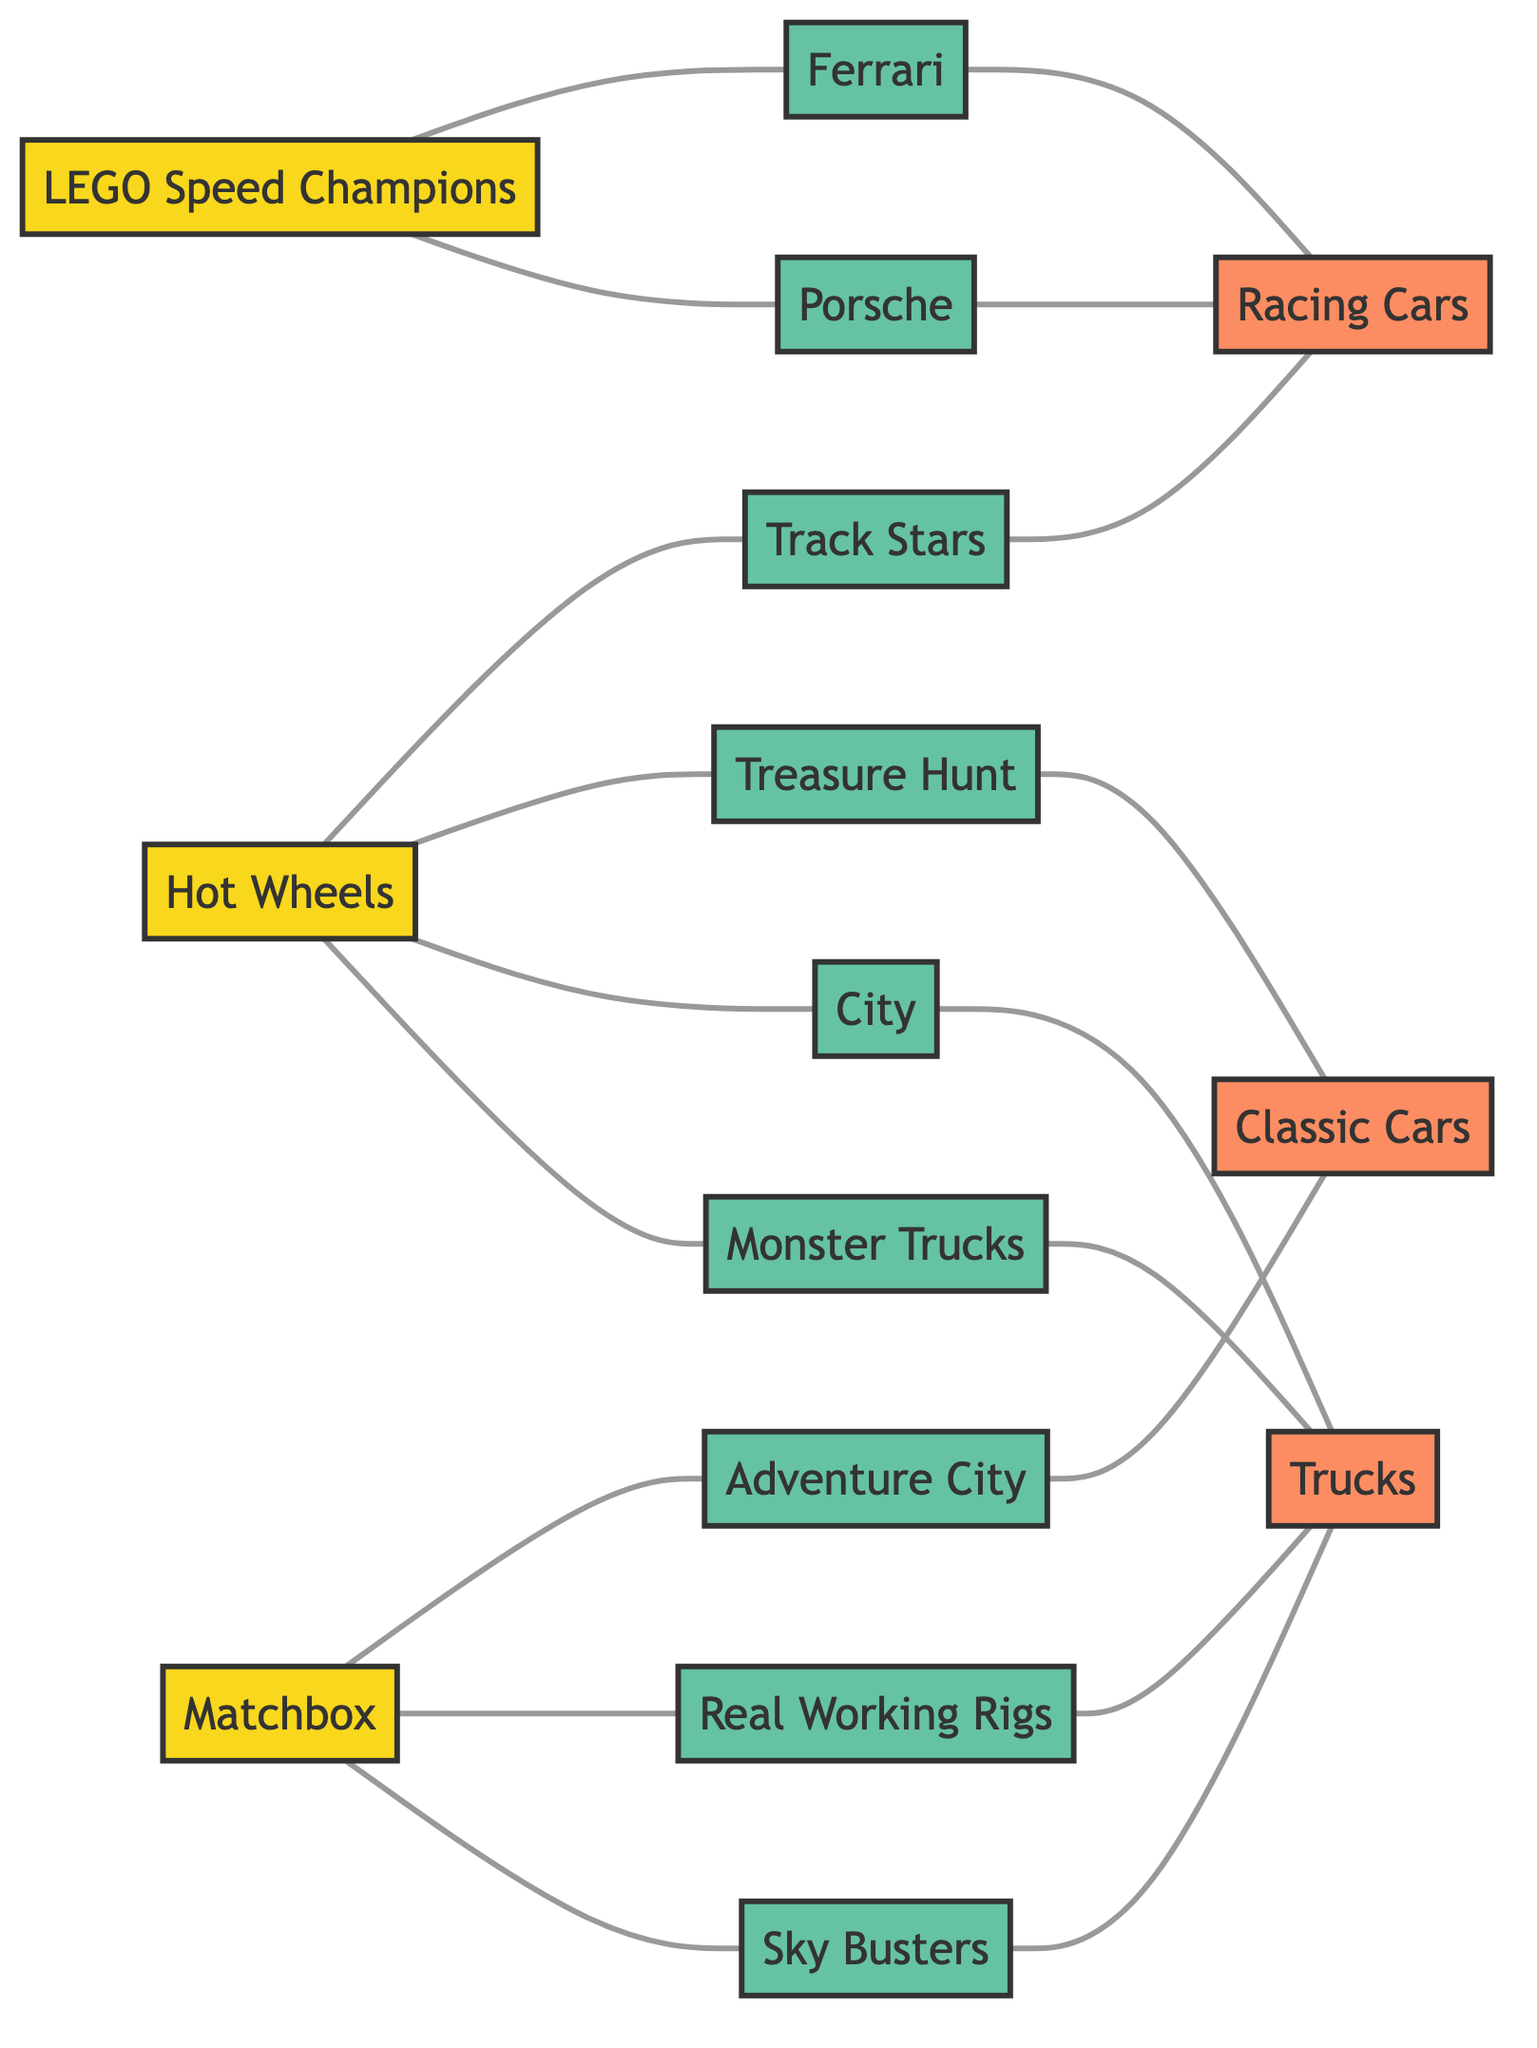What is the total number of nodes in the diagram? The diagram contains 15 distinct nodes, which are represented as individual entities like manufacturers, series, or themes related to model cars.
Answer: 15 Which manufacturer is connected to the theme of "Racing Cars"? The "Hot Wheels" series connects to the "Racing Cars" theme through its connection with "Track Stars." Thus, "Hot Wheels" is the manufacturer linked to this theme.
Answer: Hot Wheels How many edges connect "Matchbox" to its series? "Matchbox" is connected to three series: "Adventure City," "Real Working Rigs," and "Sky Busters." Therefore, there are three edges connecting it to these series.
Answer: 3 What theme is associated with "LEGO Speed Champions: Ferrari"? The "LEGO Speed Champions: Ferrari" node connects to the "Racing Cars" theme, presented in the graph through its edge connection.
Answer: Racing Cars Which series of "Hot Wheels" connects to the theme of "Classic Cars"? The edge between "Hot Wheels: Treasure Hunt" and the "Classic Cars" theme demonstrates this connection, meaning the "Treasure Hunt" series connects to the "Classic Cars" theme.
Answer: Treasure Hunt Which series is linked to the theme of "Trucks"? The "Hot Wheels: City" series is associated with the "Trucks" theme as indicated by the edge connecting these two nodes in the diagram.
Answer: City What is the connection between "Matchbox" and "Sky Busters"? "Matchbox" is connected to "Sky Busters" via a direct edge, demonstrating their relationship in the model car collection.
Answer: Direct connection Which series does "Hot Wheels: Monster Trucks" connect to? The "Hot Wheels: Monster Trucks" series connects to the "Trucks" theme based on the edge that links these two elements in the graph.
Answer: Trucks Which series is connected to "LEGO Speed Champions: Porsche"? The "LEGO Speed Champions: Porsche" has an edge connecting it to the "Racing Cars" theme, meaning they are directly related through this connection.
Answer: Racing Cars 